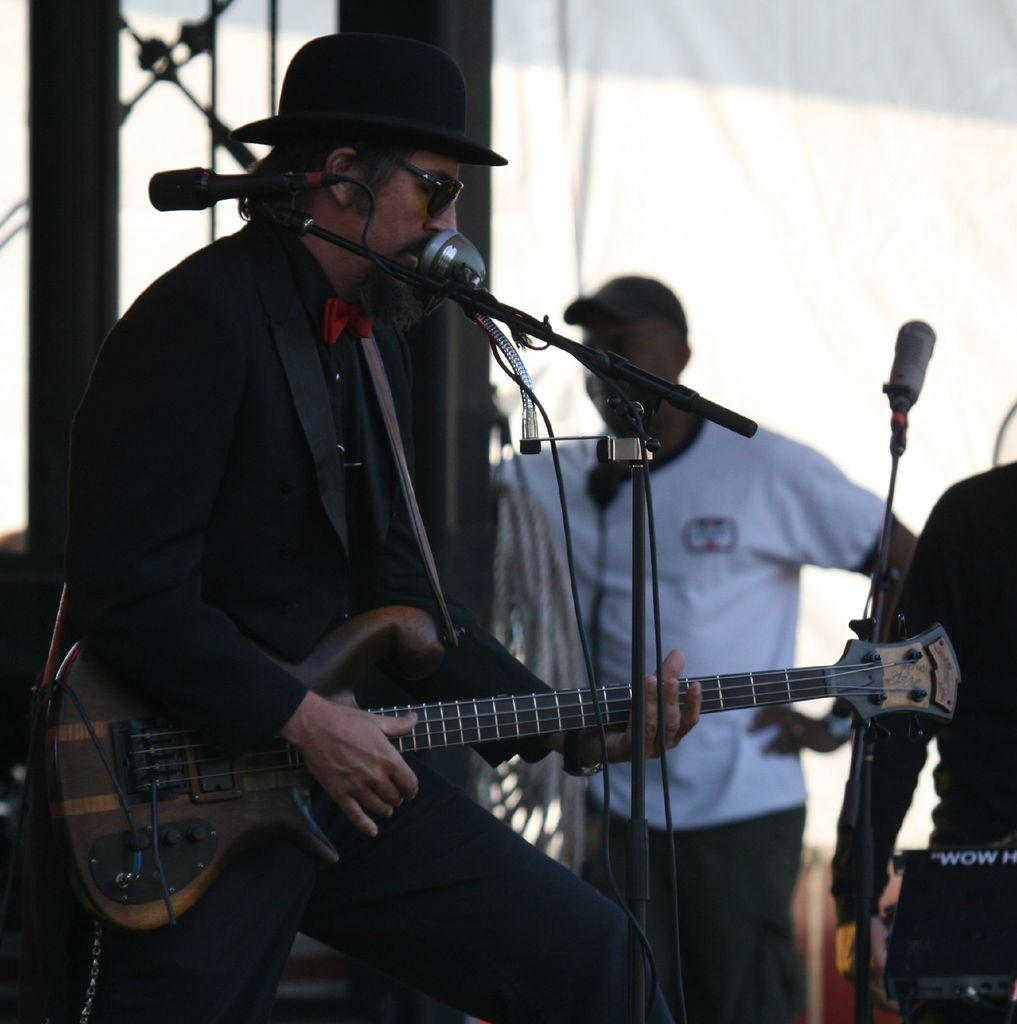What is the man in the image holding? The man is holding a guitar. What object is in front of the man? There is a microphone in front of the man. What might the man be doing in the image? The man might be playing the guitar and singing into the microphone. What type of rod is the man using to teach his mother in the image? There is no rod or teaching activity present in the image; the man is holding a guitar and there is a microphone in front of him. 